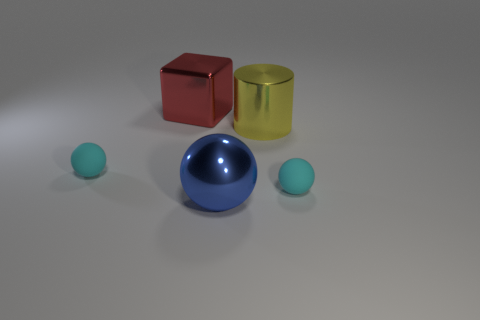How big is the metal block?
Ensure brevity in your answer.  Large. Is the size of the metal cylinder the same as the cyan ball left of the large blue object?
Give a very brief answer. No. There is a large metal cube that is right of the small cyan object behind the cyan thing that is on the right side of the yellow thing; what is its color?
Give a very brief answer. Red. Is the tiny object on the left side of the blue metallic thing made of the same material as the large ball?
Your answer should be very brief. No. What number of other things are there of the same material as the big red block
Your answer should be very brief. 2. There is a cylinder that is the same size as the red metallic block; what is it made of?
Make the answer very short. Metal. Is the shape of the shiny object on the left side of the metal ball the same as the cyan thing on the right side of the big blue metallic ball?
Your response must be concise. No. The red metal object that is the same size as the yellow metal cylinder is what shape?
Make the answer very short. Cube. Does the cyan sphere that is on the right side of the large yellow metallic cylinder have the same material as the cyan object that is left of the red metallic block?
Make the answer very short. Yes. There is a small matte ball that is right of the large yellow shiny object; is there a cylinder that is right of it?
Ensure brevity in your answer.  No. 